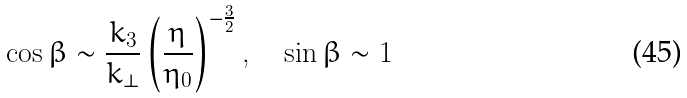<formula> <loc_0><loc_0><loc_500><loc_500>\cos \beta \sim \frac { k _ { 3 } } { k _ { \perp } } \left ( \frac { \eta } { \eta _ { 0 } } \right ) ^ { - \frac { 3 } { 2 } } , \quad \sin \beta \sim 1</formula> 